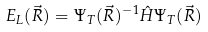Convert formula to latex. <formula><loc_0><loc_0><loc_500><loc_500>E _ { L } ( \vec { R } ) = \Psi _ { T } ( \vec { R } ) ^ { - 1 } \hat { H } \Psi _ { T } ( \vec { R } )</formula> 